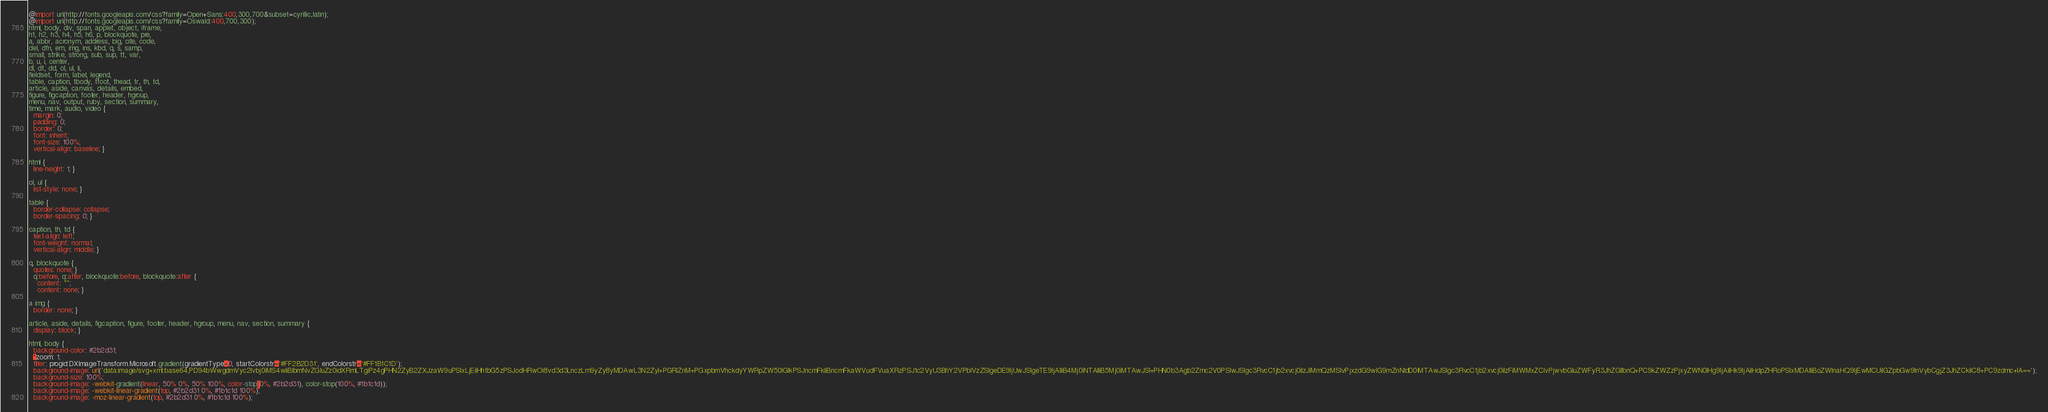<code> <loc_0><loc_0><loc_500><loc_500><_CSS_>@import url(http://fonts.googleapis.com/css?family=Open+Sans:400,300,700&subset=cyrillic,latin);
@import url(http://fonts.googleapis.com/css?family=Oswald:400,700,300);
html, body, div, span, applet, object, iframe,
h1, h2, h3, h4, h5, h6, p, blockquote, pre,
a, abbr, acronym, address, big, cite, code,
del, dfn, em, img, ins, kbd, q, s, samp,
small, strike, strong, sub, sup, tt, var,
b, u, i, center,
dl, dt, dd, ol, ul, li,
fieldset, form, label, legend,
table, caption, tbody, tfoot, thead, tr, th, td,
article, aside, canvas, details, embed,
figure, figcaption, footer, header, hgroup,
menu, nav, output, ruby, section, summary,
time, mark, audio, video {
  margin: 0;
  padding: 0;
  border: 0;
  font: inherit;
  font-size: 100%;
  vertical-align: baseline; }

html {
  line-height: 1; }

ol, ul {
  list-style: none; }

table {
  border-collapse: collapse;
  border-spacing: 0; }

caption, th, td {
  text-align: left;
  font-weight: normal;
  vertical-align: middle; }

q, blockquote {
  quotes: none; }
  q:before, q:after, blockquote:before, blockquote:after {
    content: "";
    content: none; }

a img {
  border: none; }

article, aside, details, figcaption, figure, footer, header, hgroup, menu, nav, section, summary {
  display: block; }

html, body {
  background-color: #2b2d31;
  *zoom: 1;
  filter: progid:DXImageTransform.Microsoft.gradient(gradientType=0, startColorstr='#FF2B2D31', endColorstr='#FF1B1C1D');
  background-image: url('data:image/svg+xml;base64,PD94bWwgdmVyc2lvbj0iMS4wIiBlbmNvZGluZz0idXRmLTgiPz4gPHN2ZyB2ZXJzaW9uPSIxLjEiIHhtbG5zPSJodHRwOi8vd3d3LnczLm9yZy8yMDAwL3N2ZyI+PGRlZnM+PGxpbmVhckdyYWRpZW50IGlkPSJncmFkIiBncmFkaWVudFVuaXRzPSJ1c2VyU3BhY2VPblVzZSIgeDE9IjUwJSIgeTE9IjAlIiB4Mj0iNTAlIiB5Mj0iMTAwJSI+PHN0b3Agb2Zmc2V0PSIwJSIgc3RvcC1jb2xvcj0iIzJiMmQzMSIvPjxzdG9wIG9mZnNldD0iMTAwJSIgc3RvcC1jb2xvcj0iIzFiMWMxZCIvPjwvbGluZWFyR3JhZGllbnQ+PC9kZWZzPjxyZWN0IHg9IjAiIHk9IjAiIHdpZHRoPSIxMDAlIiBoZWlnaHQ9IjEwMCUiIGZpbGw9InVybCgjZ3JhZCkiIC8+PC9zdmc+IA==');
  background-size: 100%;
  background-image: -webkit-gradient(linear, 50% 0%, 50% 100%, color-stop(0%, #2b2d31), color-stop(100%, #1b1c1d));
  background-image: -webkit-linear-gradient(top, #2b2d31 0%, #1b1c1d 100%);
  background-image: -moz-linear-gradient(top, #2b2d31 0%, #1b1c1d 100%);</code> 